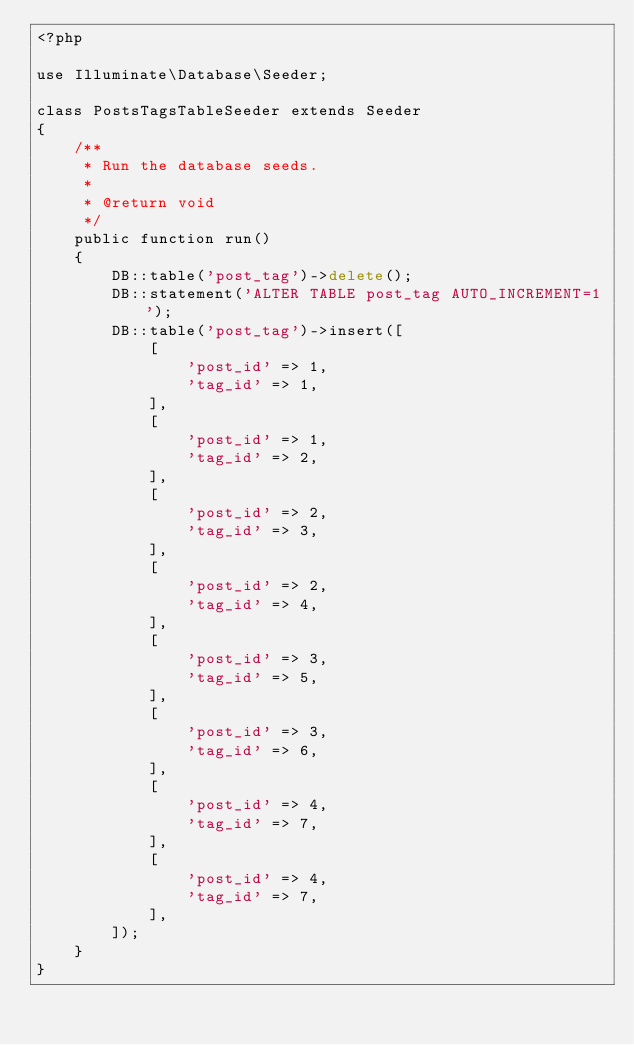Convert code to text. <code><loc_0><loc_0><loc_500><loc_500><_PHP_><?php

use Illuminate\Database\Seeder;

class PostsTagsTableSeeder extends Seeder
{
    /**
     * Run the database seeds.
     *
     * @return void
     */
    public function run()
    {
        DB::table('post_tag')->delete();
        DB::statement('ALTER TABLE post_tag AUTO_INCREMENT=1');
        DB::table('post_tag')->insert([
            [
                'post_id' => 1,
                'tag_id' => 1,
            ],
            [
                'post_id' => 1,
                'tag_id' => 2,
            ],
            [
                'post_id' => 2,
                'tag_id' => 3,
            ],
            [
                'post_id' => 2,
                'tag_id' => 4,
            ],
            [
                'post_id' => 3,
                'tag_id' => 5,
            ],
            [
                'post_id' => 3,
                'tag_id' => 6,
            ],
            [
                'post_id' => 4,
                'tag_id' => 7,
            ],
            [
                'post_id' => 4,
                'tag_id' => 7,
            ],
        ]);
    }
}
</code> 